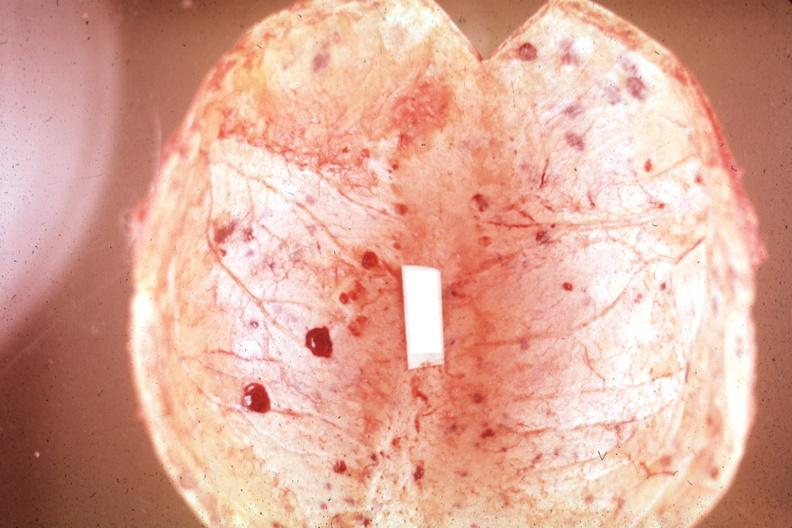re tuberculous peritonitis easily seen?
Answer the question using a single word or phrase. No 